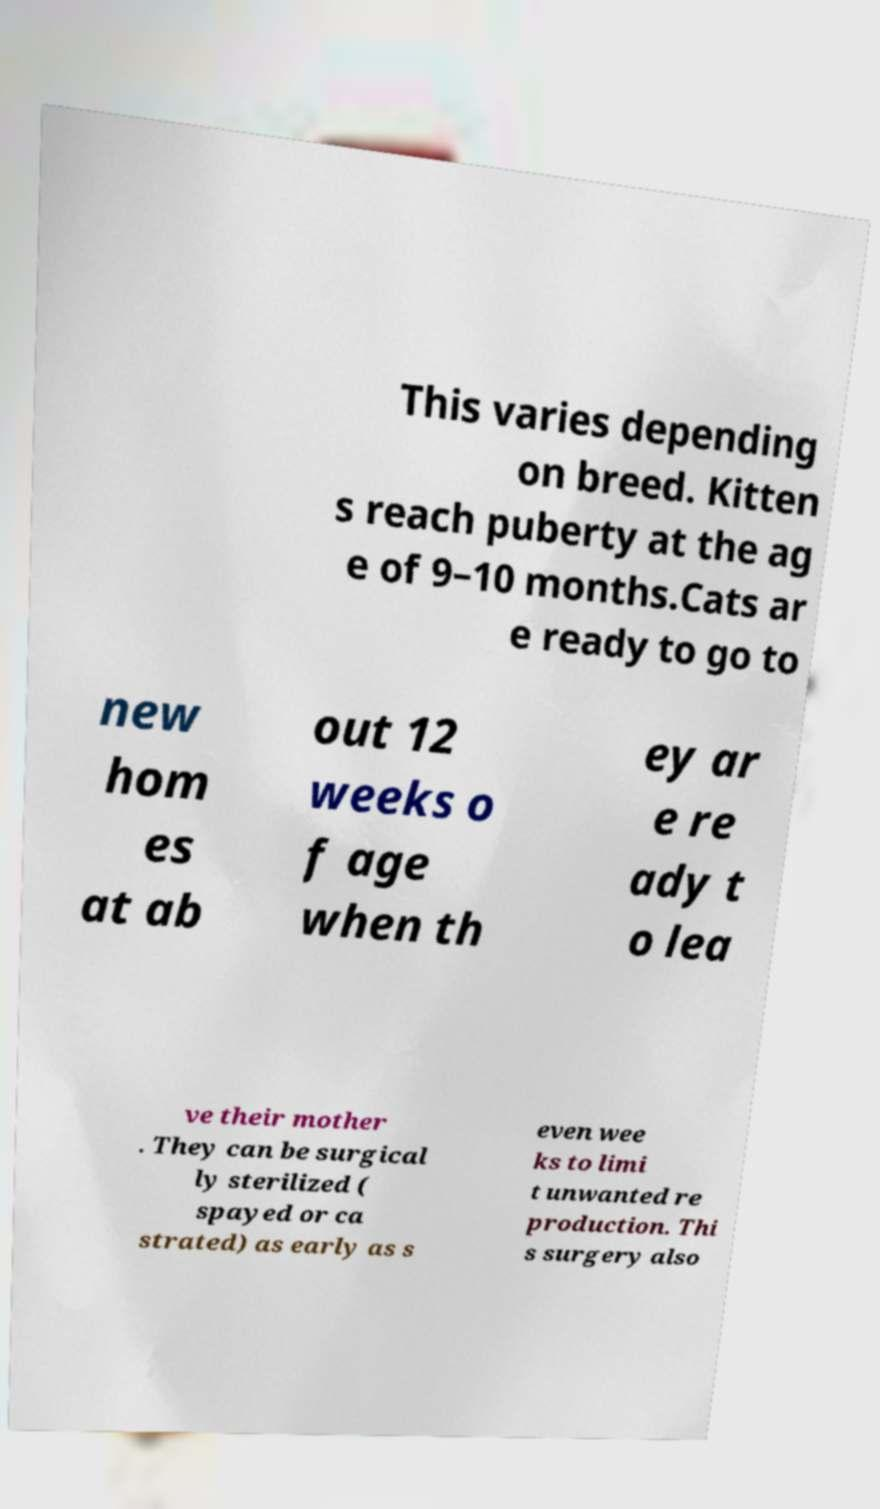Can you accurately transcribe the text from the provided image for me? This varies depending on breed. Kitten s reach puberty at the ag e of 9–10 months.Cats ar e ready to go to new hom es at ab out 12 weeks o f age when th ey ar e re ady t o lea ve their mother . They can be surgical ly sterilized ( spayed or ca strated) as early as s even wee ks to limi t unwanted re production. Thi s surgery also 